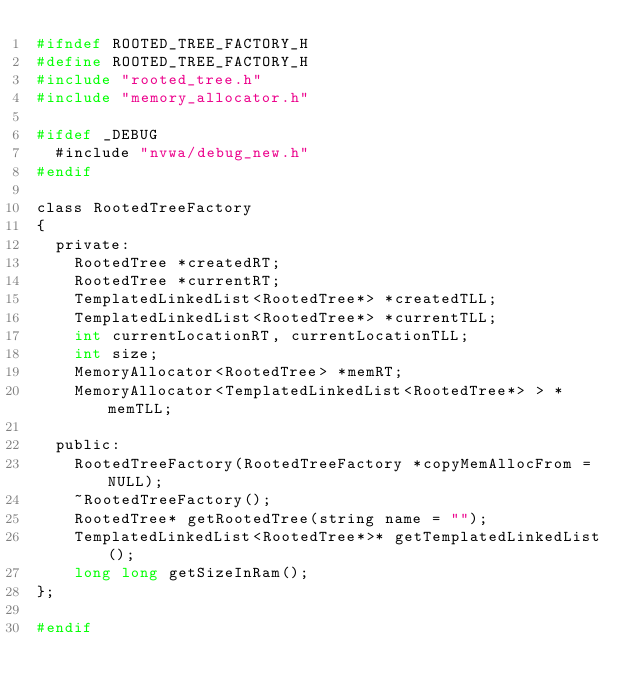<code> <loc_0><loc_0><loc_500><loc_500><_C_>#ifndef ROOTED_TREE_FACTORY_H
#define ROOTED_TREE_FACTORY_H
#include "rooted_tree.h"
#include "memory_allocator.h"

#ifdef _DEBUG
	#include "nvwa/debug_new.h"
#endif

class RootedTreeFactory
{
	private:
		RootedTree *createdRT;
		RootedTree *currentRT;
		TemplatedLinkedList<RootedTree*> *createdTLL;
		TemplatedLinkedList<RootedTree*> *currentTLL;
		int currentLocationRT, currentLocationTLL;
		int size;
		MemoryAllocator<RootedTree> *memRT;
		MemoryAllocator<TemplatedLinkedList<RootedTree*> > *memTLL;

	public:
		RootedTreeFactory(RootedTreeFactory *copyMemAllocFrom = NULL);
		~RootedTreeFactory();
		RootedTree* getRootedTree(string name = "");
		TemplatedLinkedList<RootedTree*>* getTemplatedLinkedList();
		long long getSizeInRam();
};

#endif</code> 